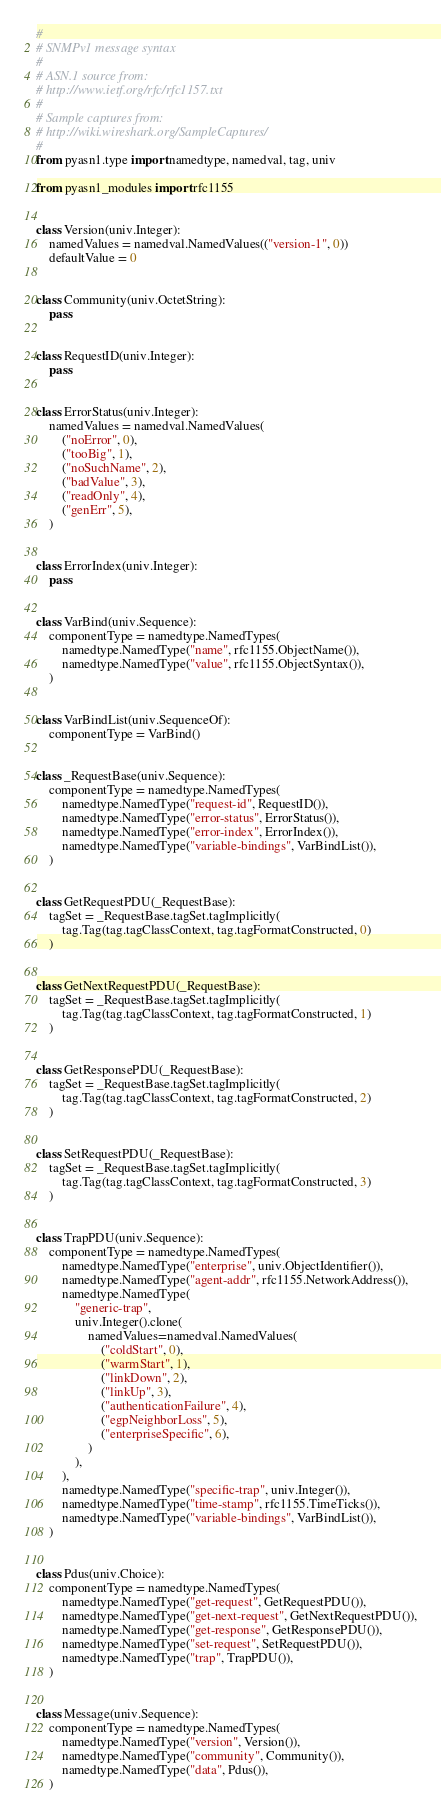<code> <loc_0><loc_0><loc_500><loc_500><_Python_>#
# SNMPv1 message syntax
#
# ASN.1 source from:
# http://www.ietf.org/rfc/rfc1157.txt
#
# Sample captures from:
# http://wiki.wireshark.org/SampleCaptures/
#
from pyasn1.type import namedtype, namedval, tag, univ

from pyasn1_modules import rfc1155


class Version(univ.Integer):
    namedValues = namedval.NamedValues(("version-1", 0))
    defaultValue = 0


class Community(univ.OctetString):
    pass


class RequestID(univ.Integer):
    pass


class ErrorStatus(univ.Integer):
    namedValues = namedval.NamedValues(
        ("noError", 0),
        ("tooBig", 1),
        ("noSuchName", 2),
        ("badValue", 3),
        ("readOnly", 4),
        ("genErr", 5),
    )


class ErrorIndex(univ.Integer):
    pass


class VarBind(univ.Sequence):
    componentType = namedtype.NamedTypes(
        namedtype.NamedType("name", rfc1155.ObjectName()),
        namedtype.NamedType("value", rfc1155.ObjectSyntax()),
    )


class VarBindList(univ.SequenceOf):
    componentType = VarBind()


class _RequestBase(univ.Sequence):
    componentType = namedtype.NamedTypes(
        namedtype.NamedType("request-id", RequestID()),
        namedtype.NamedType("error-status", ErrorStatus()),
        namedtype.NamedType("error-index", ErrorIndex()),
        namedtype.NamedType("variable-bindings", VarBindList()),
    )


class GetRequestPDU(_RequestBase):
    tagSet = _RequestBase.tagSet.tagImplicitly(
        tag.Tag(tag.tagClassContext, tag.tagFormatConstructed, 0)
    )


class GetNextRequestPDU(_RequestBase):
    tagSet = _RequestBase.tagSet.tagImplicitly(
        tag.Tag(tag.tagClassContext, tag.tagFormatConstructed, 1)
    )


class GetResponsePDU(_RequestBase):
    tagSet = _RequestBase.tagSet.tagImplicitly(
        tag.Tag(tag.tagClassContext, tag.tagFormatConstructed, 2)
    )


class SetRequestPDU(_RequestBase):
    tagSet = _RequestBase.tagSet.tagImplicitly(
        tag.Tag(tag.tagClassContext, tag.tagFormatConstructed, 3)
    )


class TrapPDU(univ.Sequence):
    componentType = namedtype.NamedTypes(
        namedtype.NamedType("enterprise", univ.ObjectIdentifier()),
        namedtype.NamedType("agent-addr", rfc1155.NetworkAddress()),
        namedtype.NamedType(
            "generic-trap",
            univ.Integer().clone(
                namedValues=namedval.NamedValues(
                    ("coldStart", 0),
                    ("warmStart", 1),
                    ("linkDown", 2),
                    ("linkUp", 3),
                    ("authenticationFailure", 4),
                    ("egpNeighborLoss", 5),
                    ("enterpriseSpecific", 6),
                )
            ),
        ),
        namedtype.NamedType("specific-trap", univ.Integer()),
        namedtype.NamedType("time-stamp", rfc1155.TimeTicks()),
        namedtype.NamedType("variable-bindings", VarBindList()),
    )


class Pdus(univ.Choice):
    componentType = namedtype.NamedTypes(
        namedtype.NamedType("get-request", GetRequestPDU()),
        namedtype.NamedType("get-next-request", GetNextRequestPDU()),
        namedtype.NamedType("get-response", GetResponsePDU()),
        namedtype.NamedType("set-request", SetRequestPDU()),
        namedtype.NamedType("trap", TrapPDU()),
    )


class Message(univ.Sequence):
    componentType = namedtype.NamedTypes(
        namedtype.NamedType("version", Version()),
        namedtype.NamedType("community", Community()),
        namedtype.NamedType("data", Pdus()),
    )
</code> 